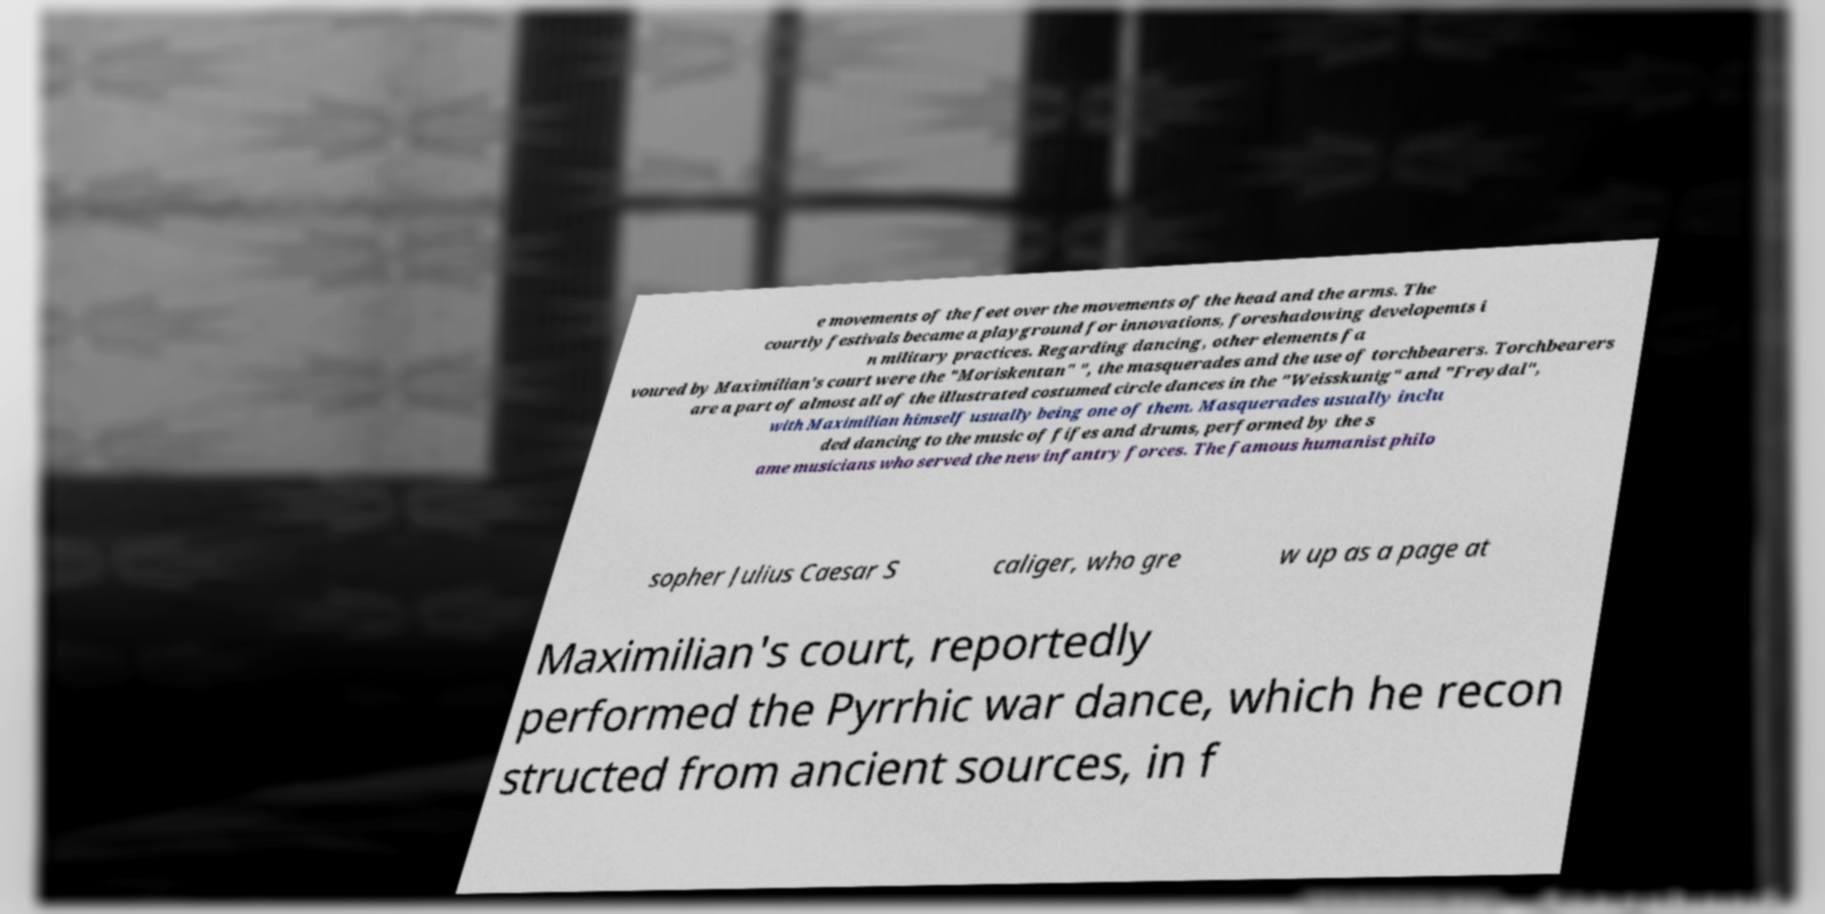For documentation purposes, I need the text within this image transcribed. Could you provide that? e movements of the feet over the movements of the head and the arms. The courtly festivals became a playground for innovations, foreshadowing developemts i n military practices. Regarding dancing, other elements fa voured by Maximilian's court were the "Moriskentan" ", the masquerades and the use of torchbearers. Torchbearers are a part of almost all of the illustrated costumed circle dances in the "Weisskunig" and "Freydal", with Maximilian himself usually being one of them. Masquerades usually inclu ded dancing to the music of fifes and drums, performed by the s ame musicians who served the new infantry forces. The famous humanist philo sopher Julius Caesar S caliger, who gre w up as a page at Maximilian's court, reportedly performed the Pyrrhic war dance, which he recon structed from ancient sources, in f 